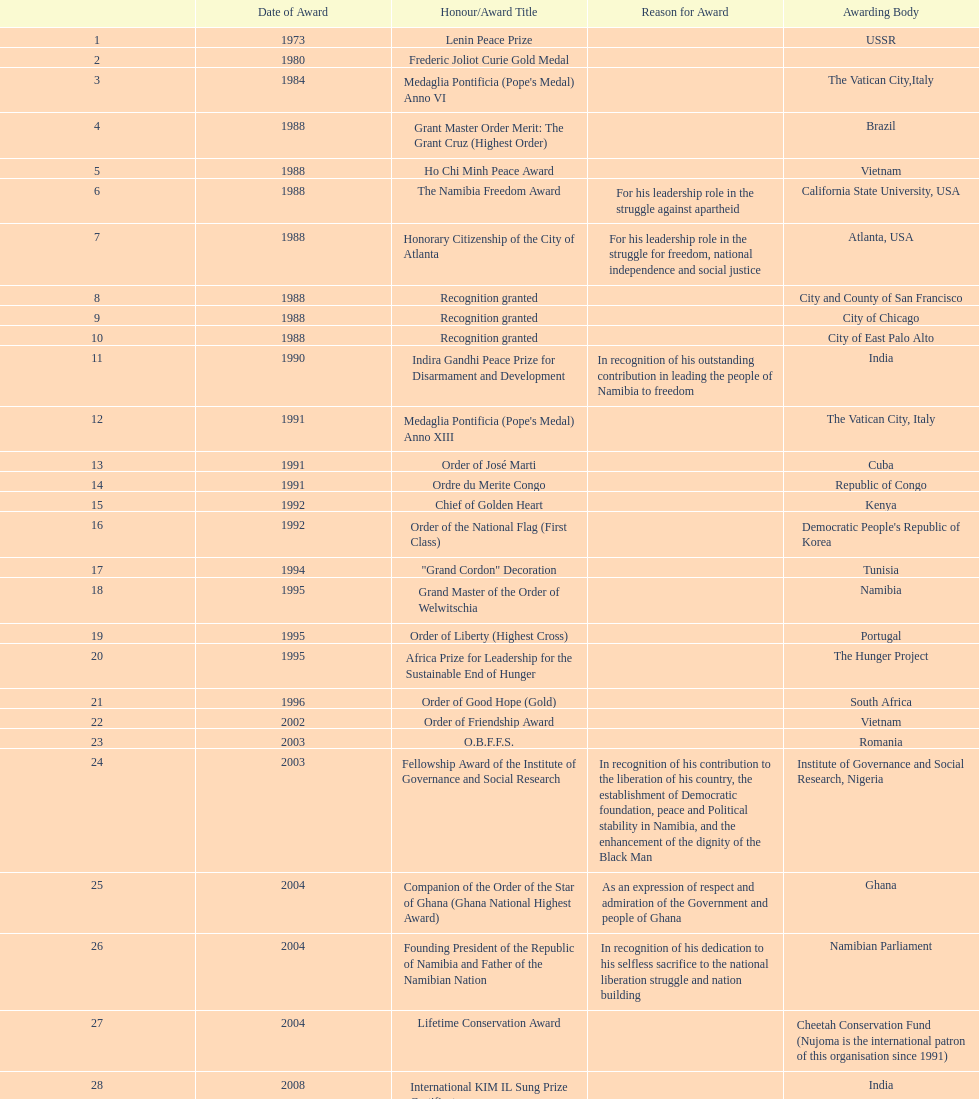What was the most recent award nujoma received? Sir Seretse Khama SADC Meda. 